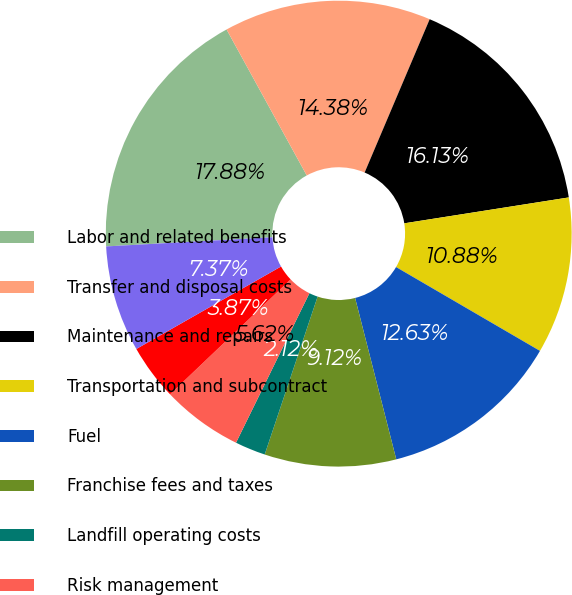Convert chart to OTSL. <chart><loc_0><loc_0><loc_500><loc_500><pie_chart><fcel>Labor and related benefits<fcel>Transfer and disposal costs<fcel>Maintenance and repairs<fcel>Transportation and subcontract<fcel>Fuel<fcel>Franchise fees and taxes<fcel>Landfill operating costs<fcel>Risk management<fcel>Cost of goods sold<fcel>Other<nl><fcel>17.88%<fcel>14.38%<fcel>16.13%<fcel>10.88%<fcel>12.63%<fcel>9.12%<fcel>2.12%<fcel>5.62%<fcel>3.87%<fcel>7.37%<nl></chart> 